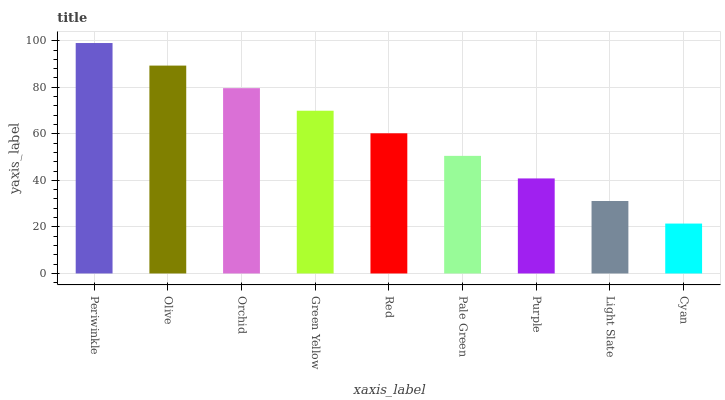Is Cyan the minimum?
Answer yes or no. Yes. Is Periwinkle the maximum?
Answer yes or no. Yes. Is Olive the minimum?
Answer yes or no. No. Is Olive the maximum?
Answer yes or no. No. Is Periwinkle greater than Olive?
Answer yes or no. Yes. Is Olive less than Periwinkle?
Answer yes or no. Yes. Is Olive greater than Periwinkle?
Answer yes or no. No. Is Periwinkle less than Olive?
Answer yes or no. No. Is Red the high median?
Answer yes or no. Yes. Is Red the low median?
Answer yes or no. Yes. Is Light Slate the high median?
Answer yes or no. No. Is Light Slate the low median?
Answer yes or no. No. 